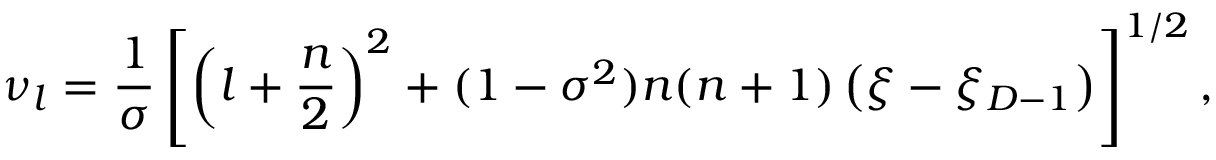Convert formula to latex. <formula><loc_0><loc_0><loc_500><loc_500>\nu _ { l } = \frac { 1 } { \sigma } \left [ \left ( l + \frac { n } { 2 } \right ) ^ { 2 } + ( 1 - \sigma ^ { 2 } ) n ( n + 1 ) \left ( \xi - \xi _ { D - 1 } \right ) \right ] ^ { 1 / 2 } ,</formula> 